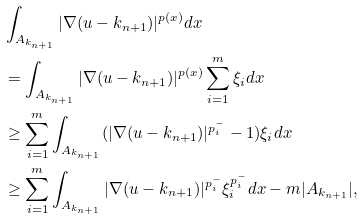<formula> <loc_0><loc_0><loc_500><loc_500>& \int _ { A _ { k _ { n + 1 } } } | \nabla ( u - k _ { n + 1 } ) | ^ { p ( x ) } d x \\ & = \int _ { A _ { k _ { n + 1 } } } | \nabla ( u - k _ { n + 1 } ) | ^ { p ( x ) } \sum _ { i = 1 } ^ { m } \xi _ { i } d x \\ & \geq \sum _ { i = 1 } ^ { m } \int _ { A _ { k _ { n + 1 } } } ( | \nabla ( u - k _ { n + 1 } ) | ^ { p ^ { - } _ { i } } - 1 ) \xi _ { i } d x \\ & \geq \sum _ { i = 1 } ^ { m } \int _ { A _ { k _ { n + 1 } } } | \nabla ( u - k _ { n + 1 } ) | ^ { p ^ { - } _ { i } } \xi _ { i } ^ { p ^ { - } _ { i } } d x - m | A _ { k _ { n + 1 } } | ,</formula> 